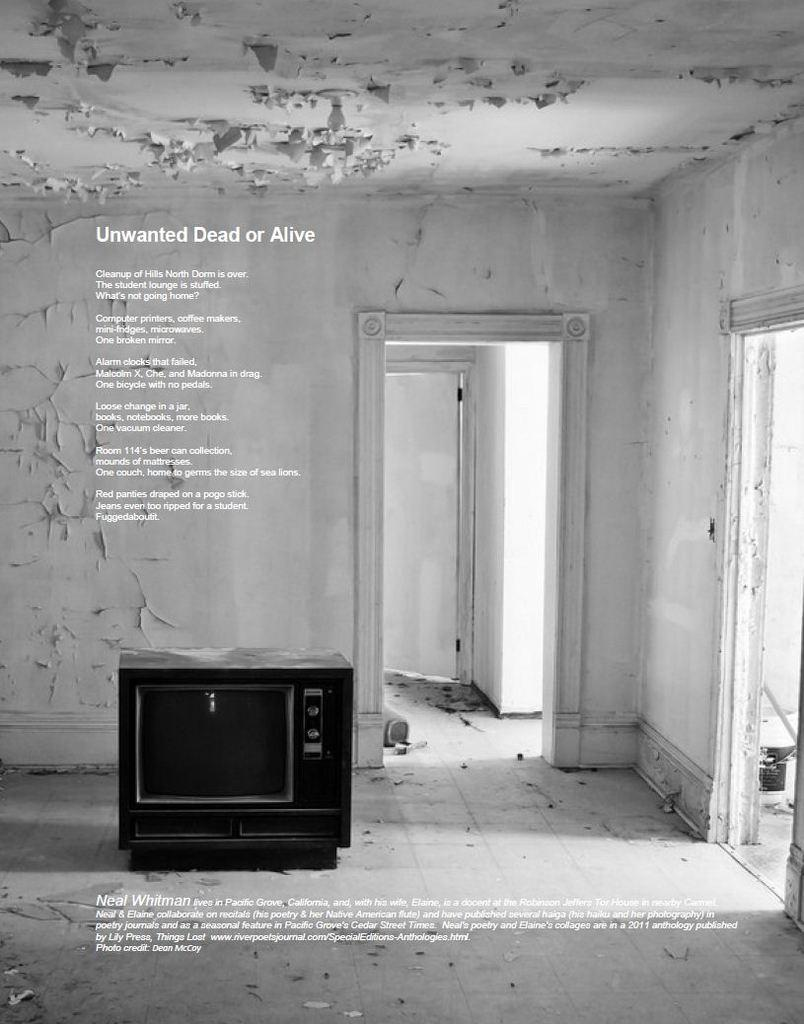<image>
Describe the image concisely. An old television sits in a broken home and words above it state that no one wants the television. 